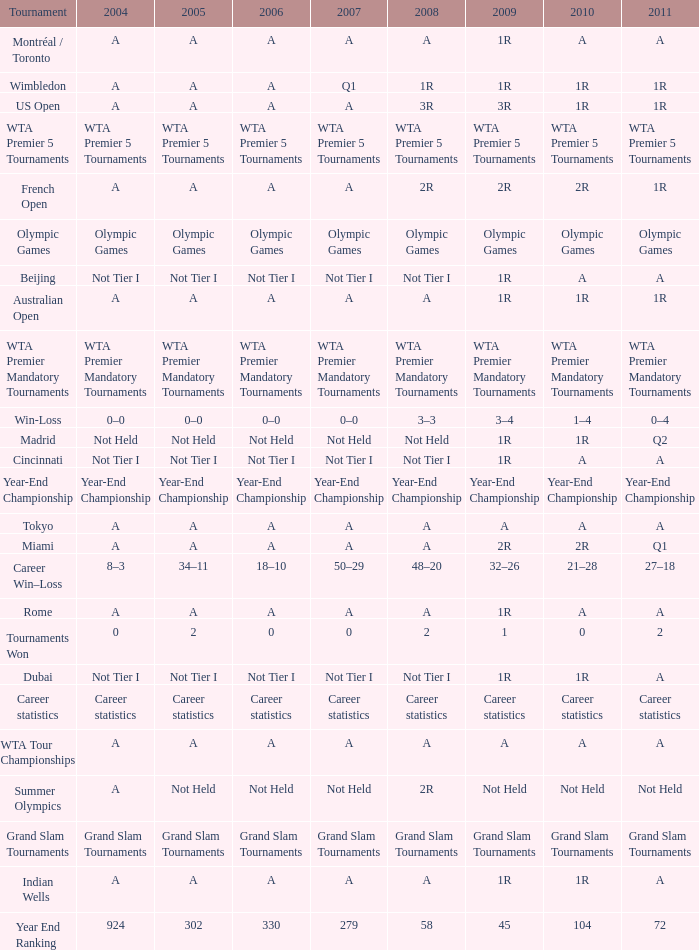What is 2007, when Tournament is "Madrid"? Not Held. 